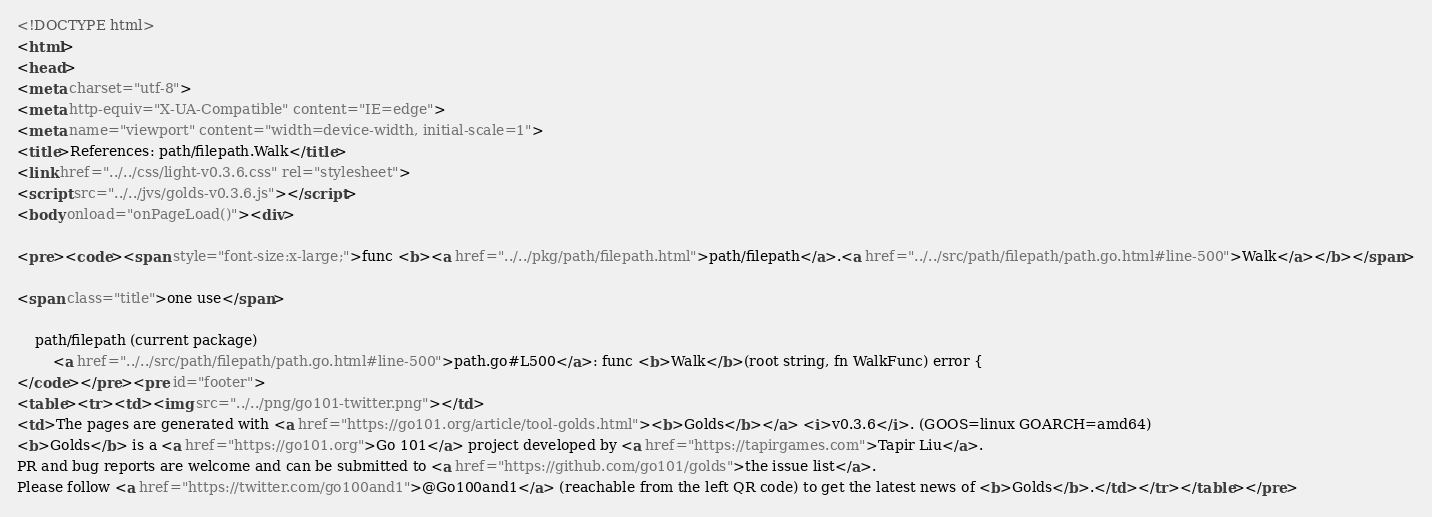Convert code to text. <code><loc_0><loc_0><loc_500><loc_500><_HTML_><!DOCTYPE html>
<html>
<head>
<meta charset="utf-8">
<meta http-equiv="X-UA-Compatible" content="IE=edge">
<meta name="viewport" content="width=device-width, initial-scale=1">
<title>References: path/filepath.Walk</title>
<link href="../../css/light-v0.3.6.css" rel="stylesheet">
<script src="../../jvs/golds-v0.3.6.js"></script>
<body onload="onPageLoad()"><div>

<pre><code><span style="font-size:x-large;">func <b><a href="../../pkg/path/filepath.html">path/filepath</a>.<a href="../../src/path/filepath/path.go.html#line-500">Walk</a></b></span>

<span class="title">one use</span>

	path/filepath (current package)
		<a href="../../src/path/filepath/path.go.html#line-500">path.go#L500</a>: func <b>Walk</b>(root string, fn WalkFunc) error {
</code></pre><pre id="footer">
<table><tr><td><img src="../../png/go101-twitter.png"></td>
<td>The pages are generated with <a href="https://go101.org/article/tool-golds.html"><b>Golds</b></a> <i>v0.3.6</i>. (GOOS=linux GOARCH=amd64)
<b>Golds</b> is a <a href="https://go101.org">Go 101</a> project developed by <a href="https://tapirgames.com">Tapir Liu</a>.
PR and bug reports are welcome and can be submitted to <a href="https://github.com/go101/golds">the issue list</a>.
Please follow <a href="https://twitter.com/go100and1">@Go100and1</a> (reachable from the left QR code) to get the latest news of <b>Golds</b>.</td></tr></table></pre></code> 